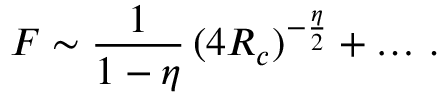Convert formula to latex. <formula><loc_0><loc_0><loc_500><loc_500>F \sim \frac { 1 } { 1 - \eta } \, ( 4 R _ { c } ) ^ { - { \frac { \eta } { 2 } } } + \dots \, .</formula> 